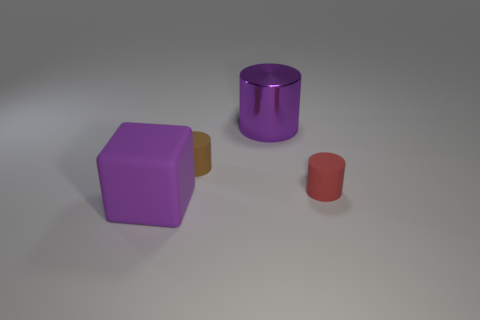The large object that is made of the same material as the brown cylinder is what shape?
Offer a very short reply. Cube. What is the shape of the metal thing that is the same size as the block?
Provide a succinct answer. Cylinder. Are there any large matte objects of the same shape as the tiny red object?
Your answer should be compact. No. How many cubes are made of the same material as the brown thing?
Your answer should be compact. 1. Are the small cylinder that is on the left side of the red rubber object and the small red cylinder made of the same material?
Offer a very short reply. Yes. Is the number of brown matte objects right of the metallic object greater than the number of tiny objects to the left of the small brown thing?
Make the answer very short. No. There is a red cylinder that is the same size as the brown cylinder; what material is it?
Give a very brief answer. Rubber. What number of other things are there of the same material as the tiny brown cylinder
Offer a very short reply. 2. Is the shape of the small object left of the tiny red matte object the same as the object that is behind the tiny brown rubber thing?
Provide a succinct answer. Yes. How many other things are the same color as the cube?
Ensure brevity in your answer.  1. 